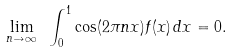<formula> <loc_0><loc_0><loc_500><loc_500>\lim _ { n \to \infty } \ \int _ { 0 } ^ { 1 } \cos ( 2 \pi n x ) f ( x ) \, d x = 0 .</formula> 